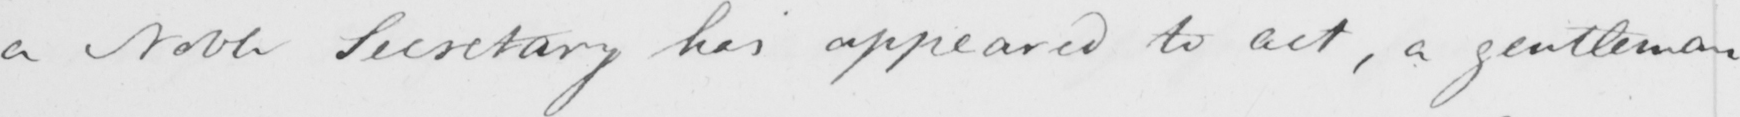Transcribe the text shown in this historical manuscript line. a Noble Secretary hias appeared to act , a gentleman 